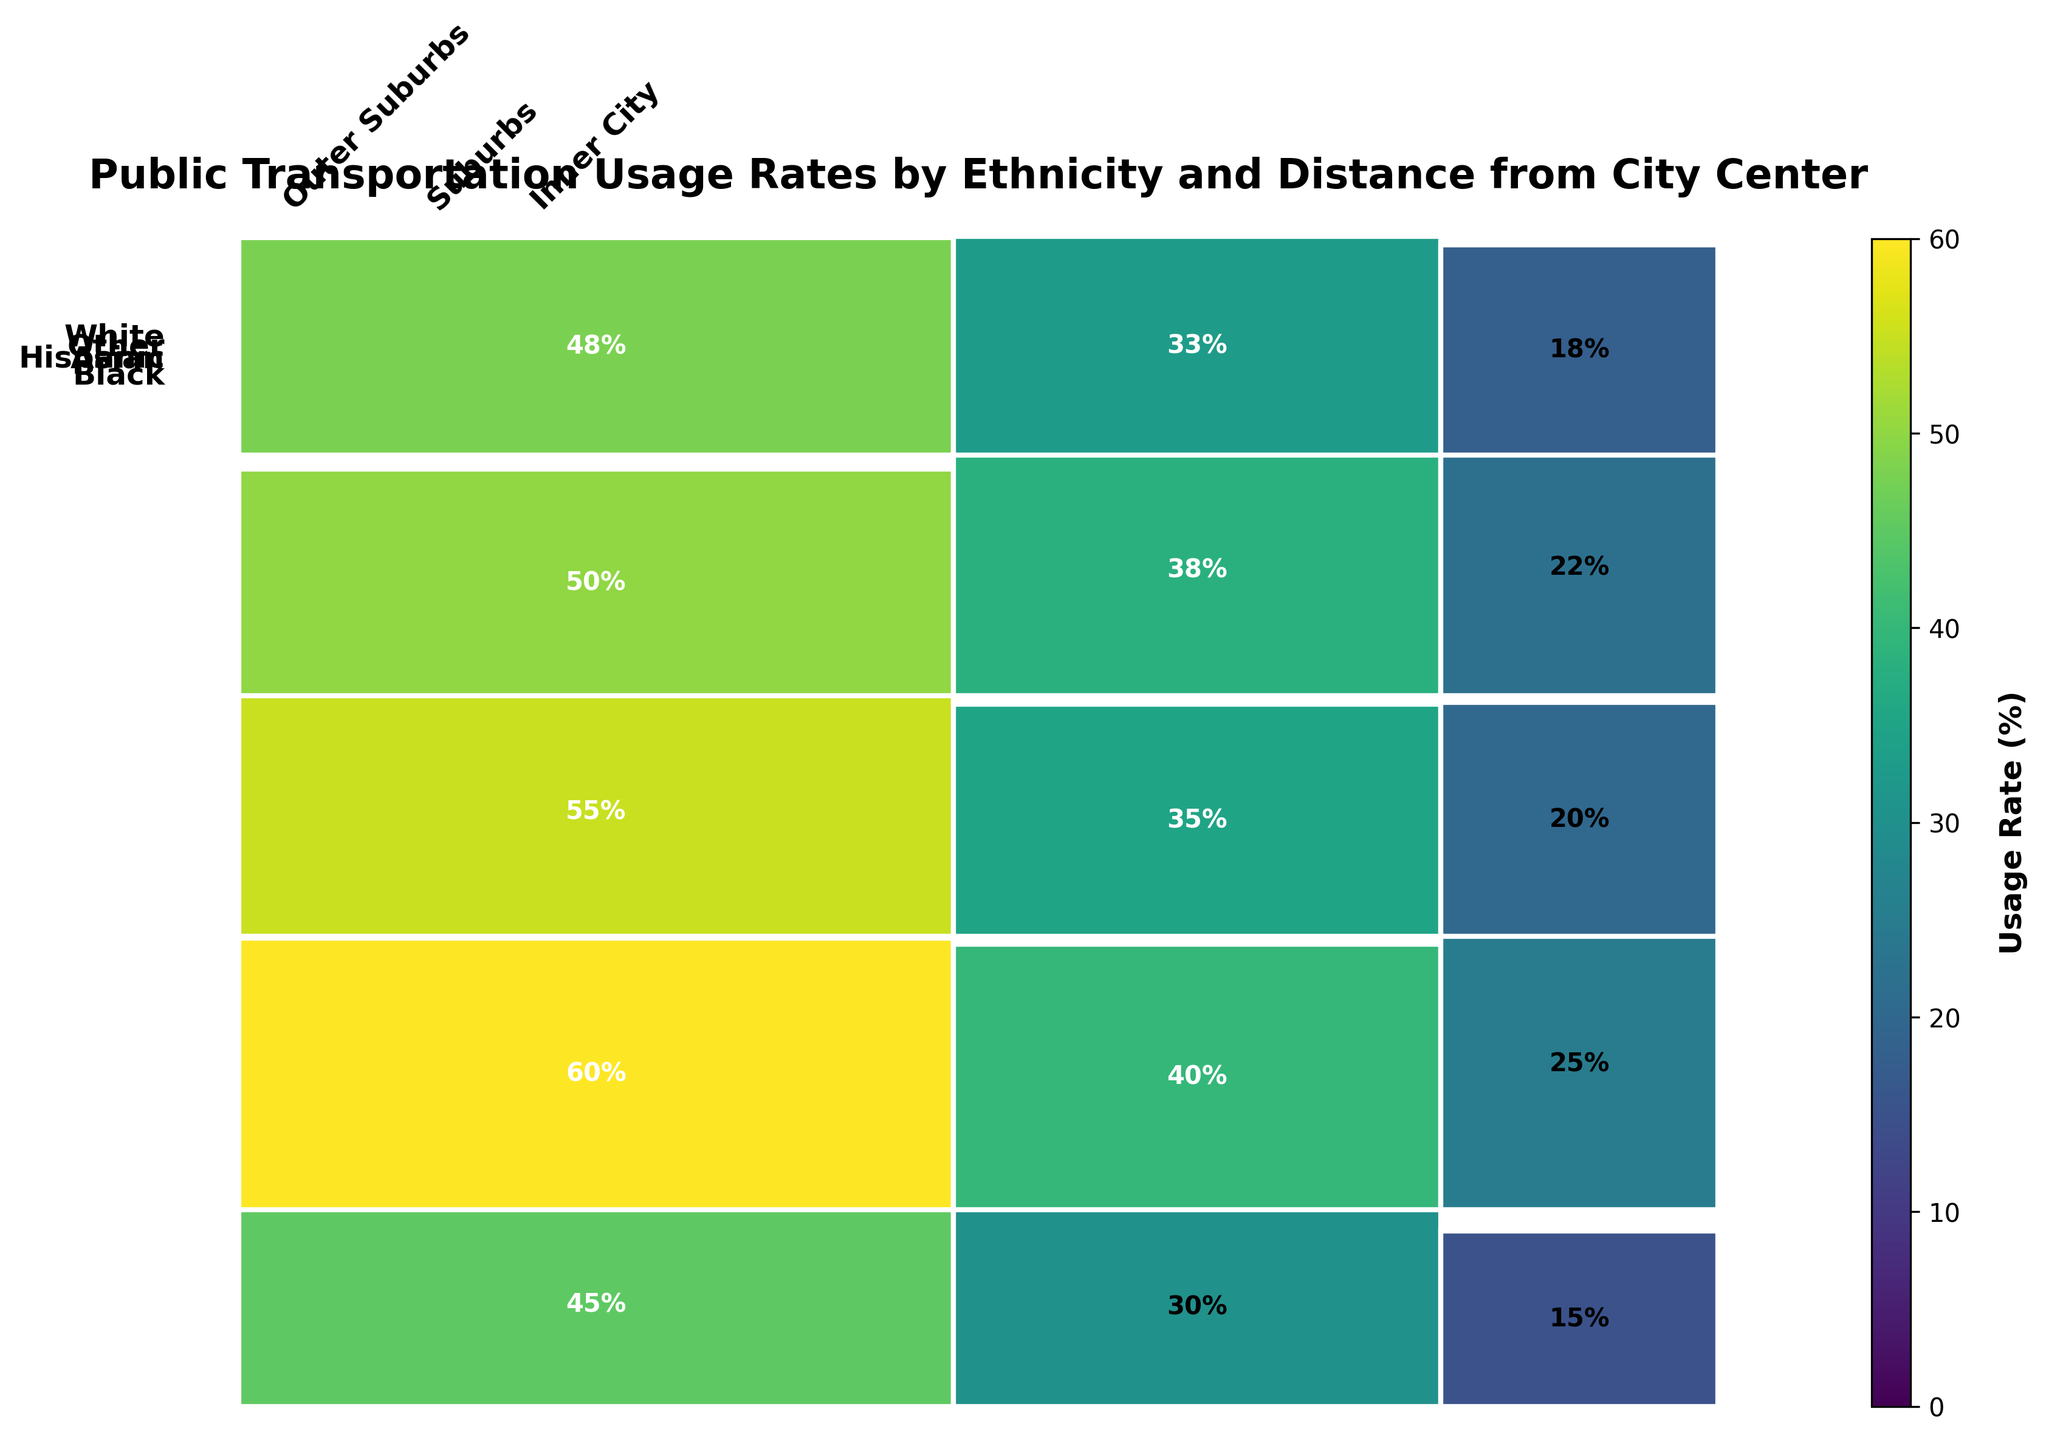What's the title of the figure? The title is located at the top of the figure and it reads "Public Transportation Usage Rates by Ethnicity and Distance from City Center".
Answer: Public Transportation Usage Rates by Ethnicity and Distance from City Center Which ethnicity has the highest public transportation usage rate in the Inner City? Look at the section representing the Inner City and compare the heights of the rectangles for each ethnicity. The Black ethnicity has the tallest rectangle.
Answer: Black What is the public transportation usage rate for Hispanics in the Outer Suburbs? Identify the specific rectangle for Hispanics in the Outer Suburbs and look at the percentage number inside it, which is 20%.
Answer: 20% Among the ethnicities, what is the trend in usage rates as the distance from the city center increases? Look at each ethnicity's rectangles from Inner City to Outer Suburbs. All ethnicities show a decreasing trend in public transportation usage rates as the distance from the city center increases.
Answer: Decreasing How does the usage rate of Whites in the Suburbs compare to Asians in the Inner City? Locate the rectangles for Whites in the Suburbs and Asians in the Inner City. Whites in the Suburbs have a usage rate of 30%, while Asians in the Inner City have a rate of 50%. Compare the two values.
Answer: Asians in the Inner City have a higher usage rate Which distance category has the highest overall public transportation usage rate? Sum the usage rates for all ethnicities in each distance category. The Inner City has the highest overall public transportation usage rate.
Answer: Inner City How much greater is the public transportation usage rate of Blacks in the Outer Suburbs compared to Whites in the Outer Suburbs? Subtract the usage rate of Whites (15%) from that of Blacks (25%) in the Outer Suburbs.
Answer: 10% Which ethnic group shows the smallest decline in usage rate from Inner City to Outer Suburbs? Calculate the difference in usage rates from the Inner City to the Outer Suburbs for each ethnic group. Whites have a decline from 45% to 15% (30% decline), Blacks from 60% to 25% (35% decline), Hispanics from 55% to 20% (35% decline), Asians from 50% to 22% (28% decline), and Other from 48% to 18% (30% decline).
Answer: Asians For each ethnicity, what is the average public transportation usage rate across all distances? Sum the usage rates across Inner City, Suburbs, and Outer Suburbs for each ethnicity and divide by the number of distances (3). For Whites: (45% + 30% + 15%) / 3 = 30%; for Blacks: (60% + 40% + 25%) / 3 = 41.67%; for Hispanics: (55% + 35% + 20%) / 3 = 36.67%; for Asians: (50% + 38% + 22%) / 3 = 36.67%; for Other: (48% + 33% + 18%) / 3 = 33%.
Answer: Whites: 30%, Blacks: 41.67%, Hispanics: 36.67%, Asians: 36.67%, Other: 33% 